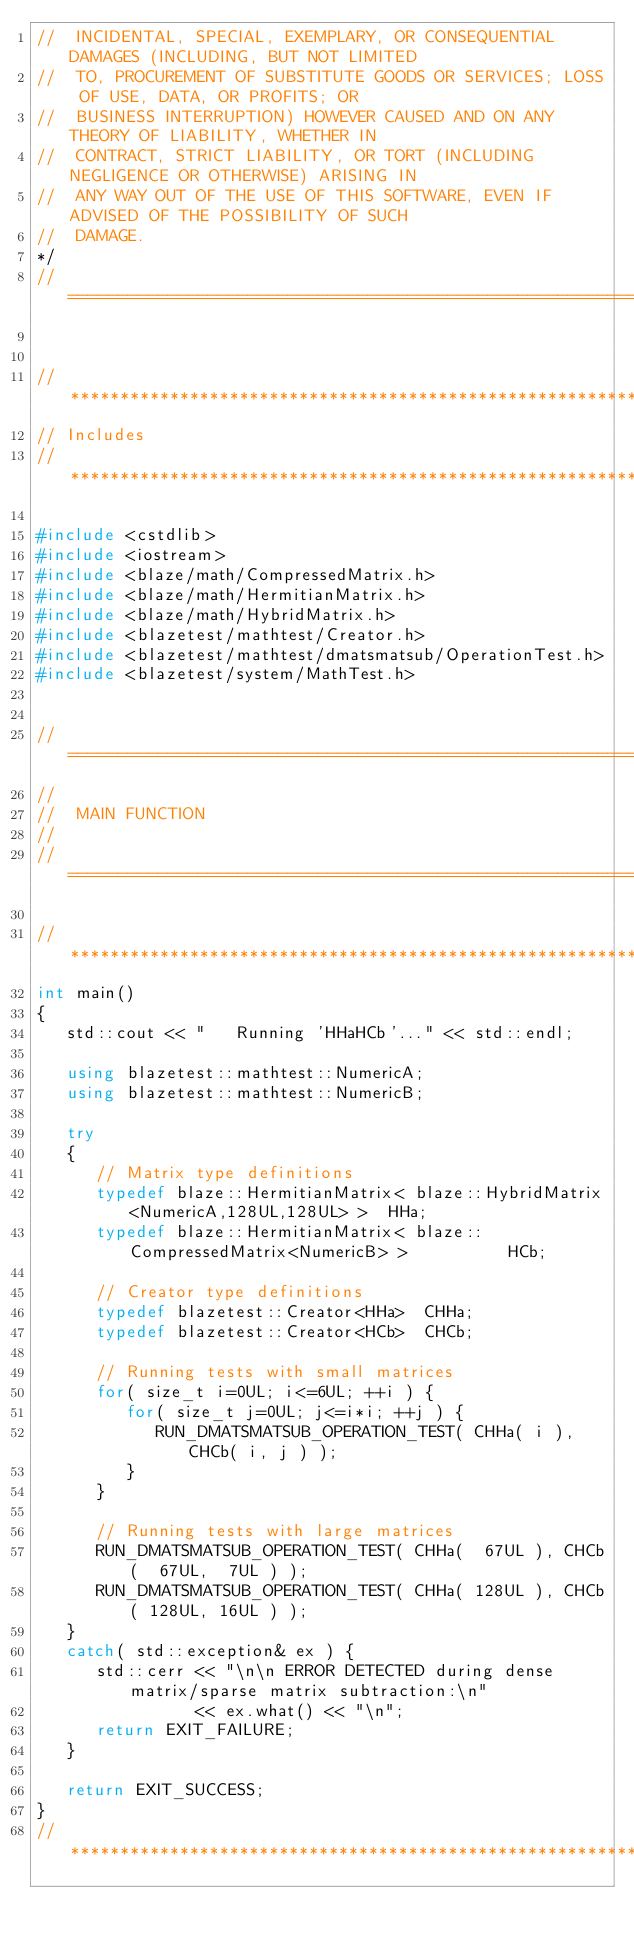Convert code to text. <code><loc_0><loc_0><loc_500><loc_500><_C++_>//  INCIDENTAL, SPECIAL, EXEMPLARY, OR CONSEQUENTIAL DAMAGES (INCLUDING, BUT NOT LIMITED
//  TO, PROCUREMENT OF SUBSTITUTE GOODS OR SERVICES; LOSS OF USE, DATA, OR PROFITS; OR
//  BUSINESS INTERRUPTION) HOWEVER CAUSED AND ON ANY THEORY OF LIABILITY, WHETHER IN
//  CONTRACT, STRICT LIABILITY, OR TORT (INCLUDING NEGLIGENCE OR OTHERWISE) ARISING IN
//  ANY WAY OUT OF THE USE OF THIS SOFTWARE, EVEN IF ADVISED OF THE POSSIBILITY OF SUCH
//  DAMAGE.
*/
//=================================================================================================


//*************************************************************************************************
// Includes
//*************************************************************************************************

#include <cstdlib>
#include <iostream>
#include <blaze/math/CompressedMatrix.h>
#include <blaze/math/HermitianMatrix.h>
#include <blaze/math/HybridMatrix.h>
#include <blazetest/mathtest/Creator.h>
#include <blazetest/mathtest/dmatsmatsub/OperationTest.h>
#include <blazetest/system/MathTest.h>


//=================================================================================================
//
//  MAIN FUNCTION
//
//=================================================================================================

//*************************************************************************************************
int main()
{
   std::cout << "   Running 'HHaHCb'..." << std::endl;

   using blazetest::mathtest::NumericA;
   using blazetest::mathtest::NumericB;

   try
   {
      // Matrix type definitions
      typedef blaze::HermitianMatrix< blaze::HybridMatrix<NumericA,128UL,128UL> >  HHa;
      typedef blaze::HermitianMatrix< blaze::CompressedMatrix<NumericB> >          HCb;

      // Creator type definitions
      typedef blazetest::Creator<HHa>  CHHa;
      typedef blazetest::Creator<HCb>  CHCb;

      // Running tests with small matrices
      for( size_t i=0UL; i<=6UL; ++i ) {
         for( size_t j=0UL; j<=i*i; ++j ) {
            RUN_DMATSMATSUB_OPERATION_TEST( CHHa( i ), CHCb( i, j ) );
         }
      }

      // Running tests with large matrices
      RUN_DMATSMATSUB_OPERATION_TEST( CHHa(  67UL ), CHCb(  67UL,  7UL ) );
      RUN_DMATSMATSUB_OPERATION_TEST( CHHa( 128UL ), CHCb( 128UL, 16UL ) );
   }
   catch( std::exception& ex ) {
      std::cerr << "\n\n ERROR DETECTED during dense matrix/sparse matrix subtraction:\n"
                << ex.what() << "\n";
      return EXIT_FAILURE;
   }

   return EXIT_SUCCESS;
}
//*************************************************************************************************
</code> 